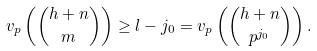Convert formula to latex. <formula><loc_0><loc_0><loc_500><loc_500>v _ { p } \left ( \binom { h + n } { m } \right ) \geq l - j _ { 0 } = v _ { p } \left ( \binom { h + n } { p ^ { j _ { 0 } } } \right ) .</formula> 